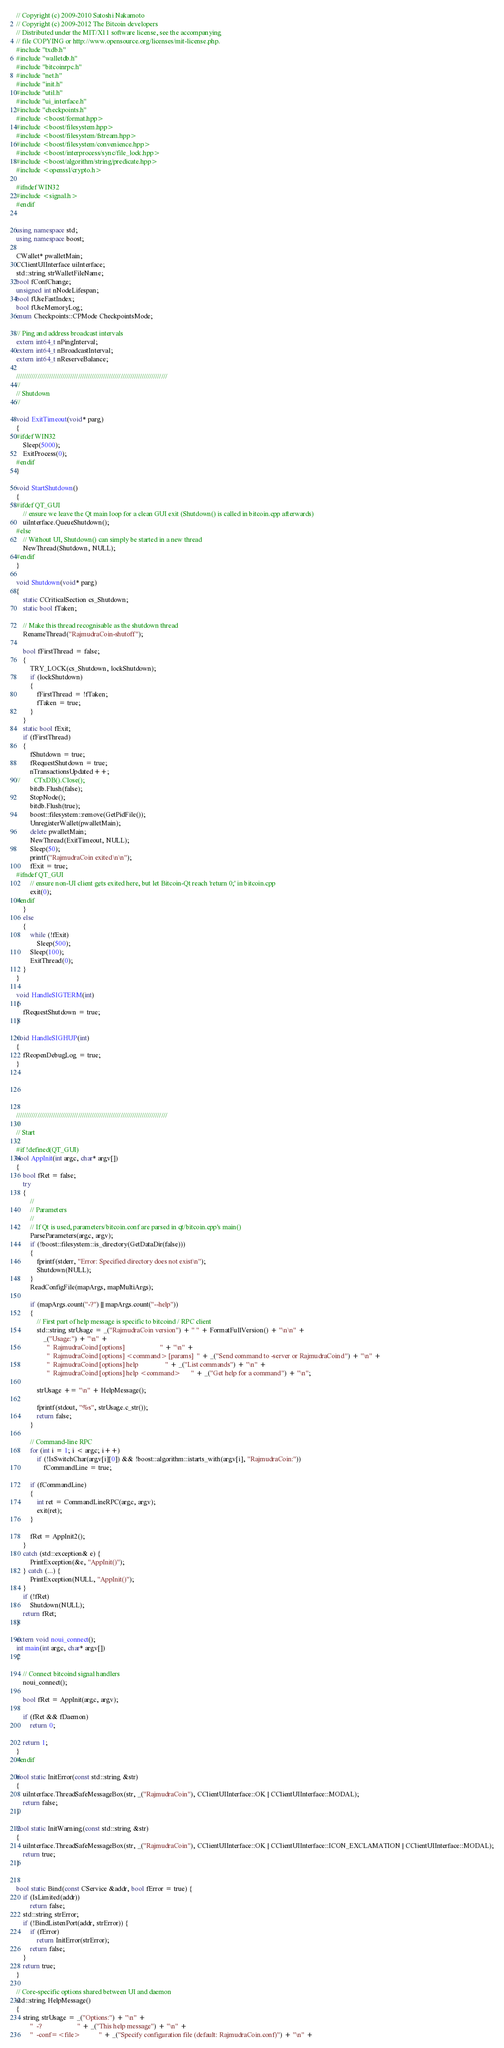<code> <loc_0><loc_0><loc_500><loc_500><_C++_>// Copyright (c) 2009-2010 Satoshi Nakamoto
// Copyright (c) 2009-2012 The Bitcoin developers
// Distributed under the MIT/X11 software license, see the accompanying
// file COPYING or http://www.opensource.org/licenses/mit-license.php.
#include "txdb.h"
#include "walletdb.h"
#include "bitcoinrpc.h"
#include "net.h"
#include "init.h"
#include "util.h"
#include "ui_interface.h"
#include "checkpoints.h"
#include <boost/format.hpp>
#include <boost/filesystem.hpp>
#include <boost/filesystem/fstream.hpp>
#include <boost/filesystem/convenience.hpp>
#include <boost/interprocess/sync/file_lock.hpp>
#include <boost/algorithm/string/predicate.hpp>
#include <openssl/crypto.h>

#ifndef WIN32
#include <signal.h>
#endif


using namespace std;
using namespace boost;

CWallet* pwalletMain;
CClientUIInterface uiInterface;
std::string strWalletFileName;
bool fConfChange;
unsigned int nNodeLifespan;
bool fUseFastIndex;
bool fUseMemoryLog;
enum Checkpoints::CPMode CheckpointsMode;

// Ping and address broadcast intervals
extern int64_t nPingInterval;
extern int64_t nBroadcastInterval;
extern int64_t nReserveBalance;

//////////////////////////////////////////////////////////////////////////////
//
// Shutdown
//

void ExitTimeout(void* parg)
{
#ifdef WIN32
    Sleep(5000);
    ExitProcess(0);
#endif
}

void StartShutdown()
{
#ifdef QT_GUI
    // ensure we leave the Qt main loop for a clean GUI exit (Shutdown() is called in bitcoin.cpp afterwards)
    uiInterface.QueueShutdown();
#else
    // Without UI, Shutdown() can simply be started in a new thread
    NewThread(Shutdown, NULL);
#endif
}

void Shutdown(void* parg)
{
    static CCriticalSection cs_Shutdown;
    static bool fTaken;

    // Make this thread recognisable as the shutdown thread
    RenameThread("RajmudraCoin-shutoff");

    bool fFirstThread = false;
    {
        TRY_LOCK(cs_Shutdown, lockShutdown);
        if (lockShutdown)
        {
            fFirstThread = !fTaken;
            fTaken = true;
        }
    }
    static bool fExit;
    if (fFirstThread)
    {
        fShutdown = true;
        fRequestShutdown = true;
        nTransactionsUpdated++;
//        CTxDB().Close();
        bitdb.Flush(false);
        StopNode();
        bitdb.Flush(true);
        boost::filesystem::remove(GetPidFile());
        UnregisterWallet(pwalletMain);
        delete pwalletMain;
        NewThread(ExitTimeout, NULL);
        Sleep(50);
        printf("RajmudraCoin exited\n\n");
        fExit = true;
#ifndef QT_GUI
        // ensure non-UI client gets exited here, but let Bitcoin-Qt reach 'return 0;' in bitcoin.cpp
        exit(0);
#endif
    }
    else
    {
        while (!fExit)
            Sleep(500);
        Sleep(100);
        ExitThread(0);
    }
}

void HandleSIGTERM(int)
{
    fRequestShutdown = true;
}

void HandleSIGHUP(int)
{
    fReopenDebugLog = true;
}





//////////////////////////////////////////////////////////////////////////////
//
// Start
//
#if !defined(QT_GUI)
bool AppInit(int argc, char* argv[])
{
    bool fRet = false;
    try
    {
        //
        // Parameters
        //
        // If Qt is used, parameters/bitcoin.conf are parsed in qt/bitcoin.cpp's main()
        ParseParameters(argc, argv);
        if (!boost::filesystem::is_directory(GetDataDir(false)))
        {
            fprintf(stderr, "Error: Specified directory does not exist\n");
            Shutdown(NULL);
        }
        ReadConfigFile(mapArgs, mapMultiArgs);

        if (mapArgs.count("-?") || mapArgs.count("--help"))
        {
            // First part of help message is specific to bitcoind / RPC client
            std::string strUsage = _("RajmudraCoin version") + " " + FormatFullVersion() + "\n\n" +
                _("Usage:") + "\n" +
                  "  RajmudraCoind [options]                     " + "\n" +
                  "  RajmudraCoind [options] <command> [params]  " + _("Send command to -server or RajmudraCoind") + "\n" +
                  "  RajmudraCoind [options] help                " + _("List commands") + "\n" +
                  "  RajmudraCoind [options] help <command>      " + _("Get help for a command") + "\n";

            strUsage += "\n" + HelpMessage();

            fprintf(stdout, "%s", strUsage.c_str());
            return false;
        }

        // Command-line RPC
        for (int i = 1; i < argc; i++)
            if (!IsSwitchChar(argv[i][0]) && !boost::algorithm::istarts_with(argv[i], "RajmudraCoin:"))
                fCommandLine = true;

        if (fCommandLine)
        {
            int ret = CommandLineRPC(argc, argv);
            exit(ret);
        }

        fRet = AppInit2();
    }
    catch (std::exception& e) {
        PrintException(&e, "AppInit()");
    } catch (...) {
        PrintException(NULL, "AppInit()");
    }
    if (!fRet)
        Shutdown(NULL);
    return fRet;
}

extern void noui_connect();
int main(int argc, char* argv[])
{

    // Connect bitcoind signal handlers
    noui_connect();

    bool fRet = AppInit(argc, argv);

    if (fRet && fDaemon)
        return 0;

    return 1;
}
#endif

bool static InitError(const std::string &str)
{
    uiInterface.ThreadSafeMessageBox(str, _("RajmudraCoin"), CClientUIInterface::OK | CClientUIInterface::MODAL);
    return false;
}

bool static InitWarning(const std::string &str)
{
    uiInterface.ThreadSafeMessageBox(str, _("RajmudraCoin"), CClientUIInterface::OK | CClientUIInterface::ICON_EXCLAMATION | CClientUIInterface::MODAL);
    return true;
}


bool static Bind(const CService &addr, bool fError = true) {
    if (IsLimited(addr))
        return false;
    std::string strError;
    if (!BindListenPort(addr, strError)) {
        if (fError)
            return InitError(strError);
        return false;
    }
    return true;
}

// Core-specific options shared between UI and daemon
std::string HelpMessage()
{
    string strUsage = _("Options:") + "\n" +
        "  -?                     " + _("This help message") + "\n" +
        "  -conf=<file>           " + _("Specify configuration file (default: RajmudraCoin.conf)") + "\n" +</code> 